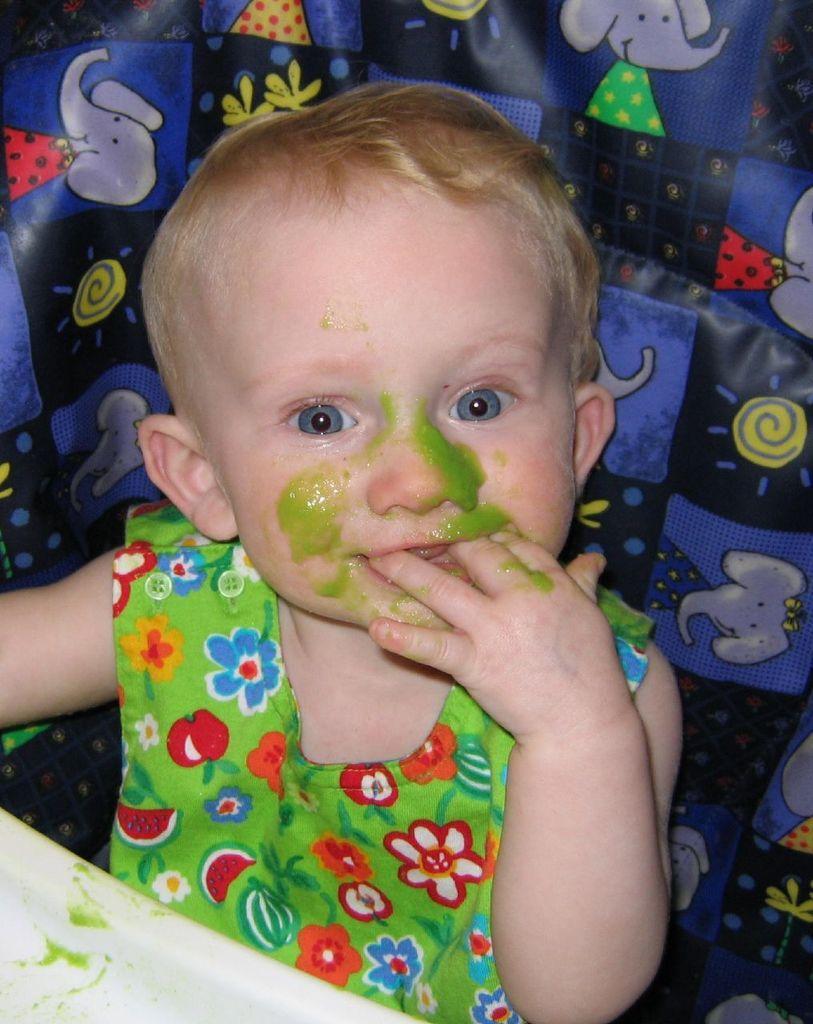Can you describe this image briefly? In this picture there is a girl who is wearing green shirt. She is sitting on the chair. In front of her there is a white plate. On his face we can see green sauce. 